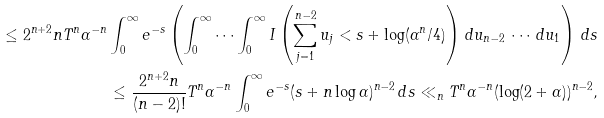Convert formula to latex. <formula><loc_0><loc_0><loc_500><loc_500>\leq 2 ^ { n + 2 } n T ^ { n } \alpha ^ { - n } \int _ { 0 } ^ { \infty } e ^ { - s } \left ( \int _ { 0 } ^ { \infty } \cdots \int _ { 0 } ^ { \infty } I \left ( \sum _ { j = 1 } ^ { n - 2 } u _ { j } < s + \log ( \alpha ^ { n } / 4 ) \right ) \, d u _ { n - 2 } \, \cdots \, d u _ { 1 } \right ) \, d s \\ \leq \frac { 2 ^ { n + 2 } n } { ( n - 2 ) ! } T ^ { n } \alpha ^ { - n } \int _ { 0 } ^ { \infty } e ^ { - s } ( s + n \log \alpha ) ^ { n - 2 } \, d s \ll _ { n } T ^ { n } \alpha ^ { - n } ( \log ( 2 + \alpha ) ) ^ { n - 2 } ,</formula> 